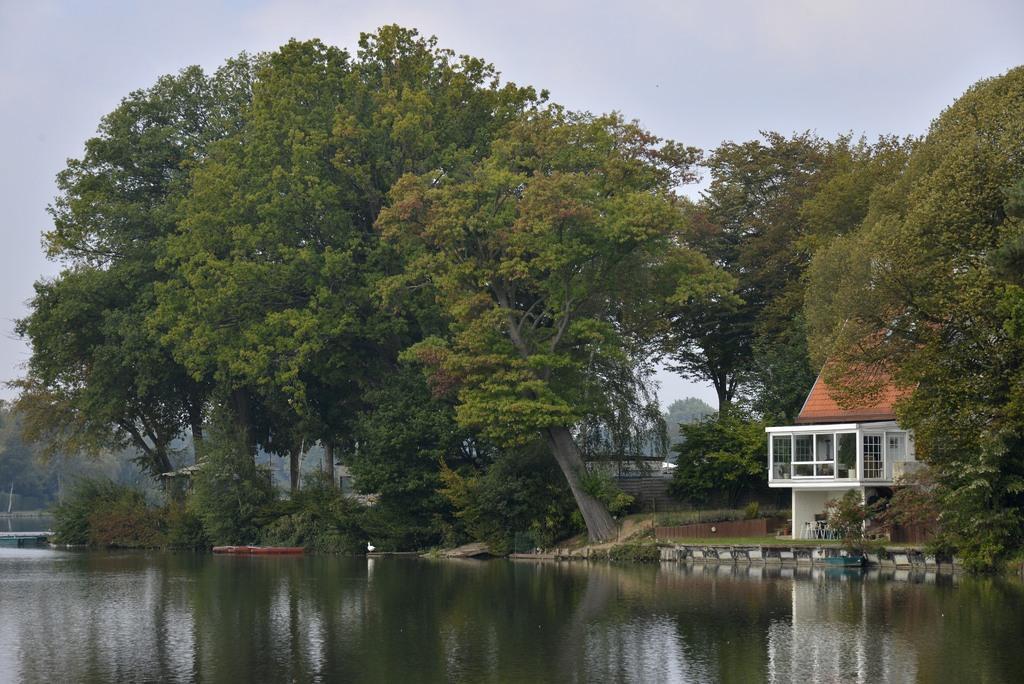Describe this image in one or two sentences. In this image there is lake in the middle. On the lake there is a boat. Beside the lake there is house on the right side and trees on the left side. At the top there is sky. There are trees on either side of the lake. 